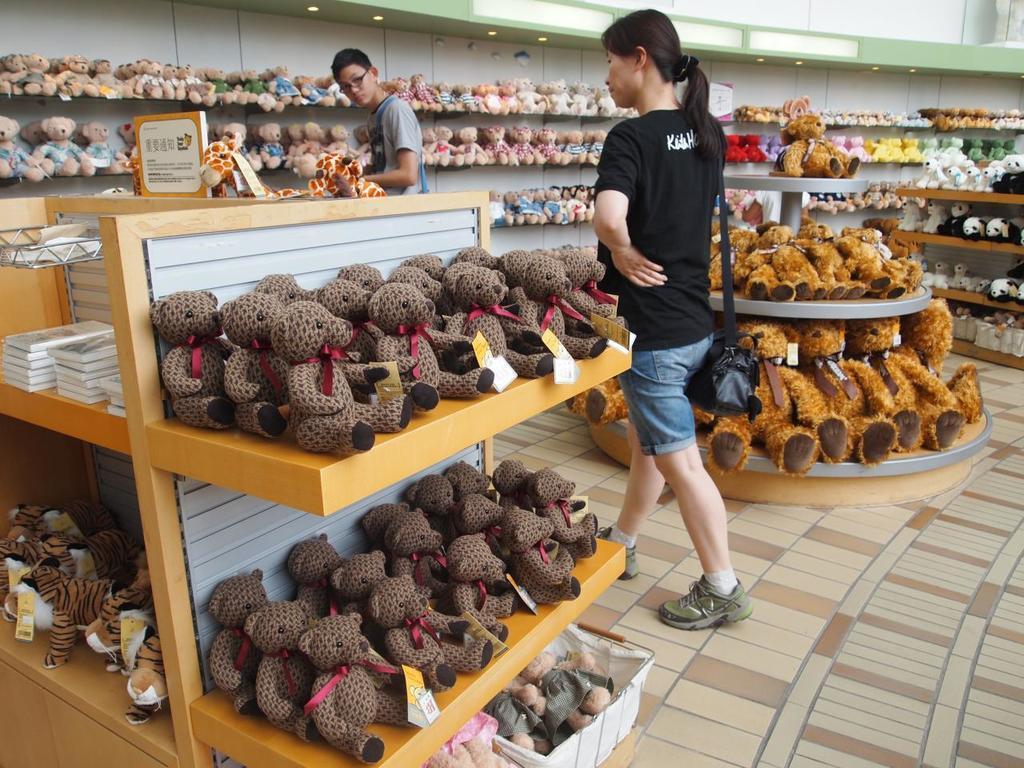In one or two sentences, can you explain what this image depicts? The image is taken inside the store. In the center of the image we can see people and there are soft toys placed in the shelves and there are lights. 